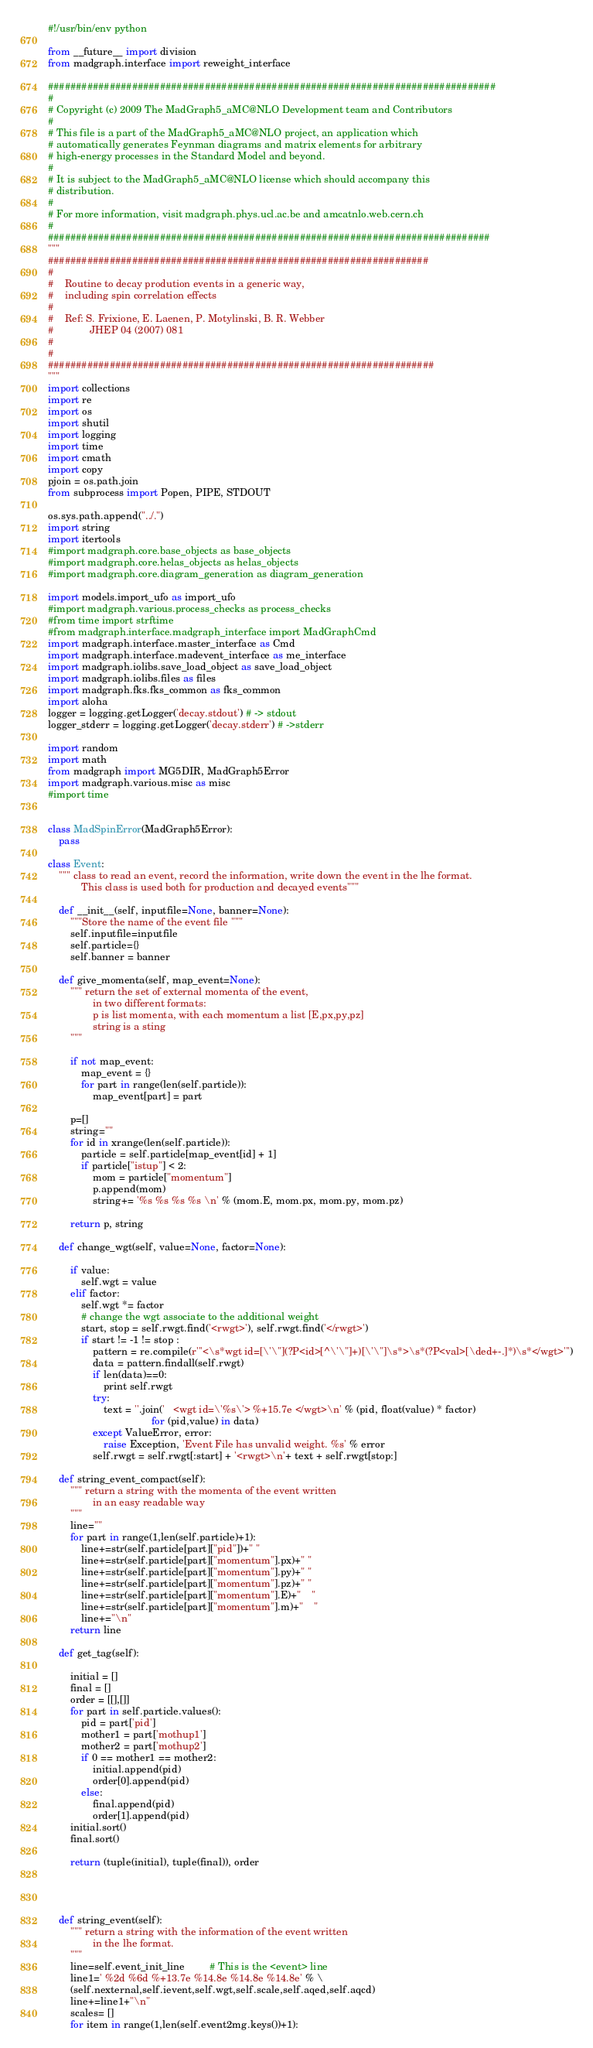<code> <loc_0><loc_0><loc_500><loc_500><_Python_>#!/usr/bin/env python

from __future__ import division
from madgraph.interface import reweight_interface

################################################################################
#
# Copyright (c) 2009 The MadGraph5_aMC@NLO Development team and Contributors
#
# This file is a part of the MadGraph5_aMC@NLO project, an application which 
# automatically generates Feynman diagrams and matrix elements for arbitrary
# high-energy processes in the Standard Model and beyond.
#
# It is subject to the MadGraph5_aMC@NLO license which should accompany this 
# distribution.
#
# For more information, visit madgraph.phys.ucl.ac.be and amcatnlo.web.cern.ch
#
###############################################################################
"""
####################################################################
#
#    Routine to decay prodution events in a generic way, 
#    including spin correlation effects
#
#    Ref: S. Frixione, E. Laenen, P. Motylinski, B. R. Webber
#             JHEP 04 (2007) 081
#
#
#####################################################################
"""
import collections
import re
import os
import shutil
import logging
import time
import cmath
import copy
pjoin = os.path.join
from subprocess import Popen, PIPE, STDOUT

os.sys.path.append("../.")
import string
import itertools
#import madgraph.core.base_objects as base_objects
#import madgraph.core.helas_objects as helas_objects
#import madgraph.core.diagram_generation as diagram_generation

import models.import_ufo as import_ufo
#import madgraph.various.process_checks as process_checks
#from time import strftime
#from madgraph.interface.madgraph_interface import MadGraphCmd
import madgraph.interface.master_interface as Cmd
import madgraph.interface.madevent_interface as me_interface
import madgraph.iolibs.save_load_object as save_load_object
import madgraph.iolibs.files as files
import madgraph.fks.fks_common as fks_common
import aloha
logger = logging.getLogger('decay.stdout') # -> stdout
logger_stderr = logging.getLogger('decay.stderr') # ->stderr

import random 
import math
from madgraph import MG5DIR, MadGraph5Error
import madgraph.various.misc as misc
#import time


class MadSpinError(MadGraph5Error):
    pass

class Event:
    """ class to read an event, record the information, write down the event in the lhe format.
            This class is used both for production and decayed events"""

    def __init__(self, inputfile=None, banner=None):
        """Store the name of the event file """
        self.inputfile=inputfile
        self.particle={}
        self.banner = banner

    def give_momenta(self, map_event=None):
        """ return the set of external momenta of the event, 
                in two different formats:
                p is list momenta, with each momentum a list [E,px,py,pz]
                string is a sting
        """
        
        if not map_event:
            map_event = {}
            for part in range(len(self.particle)):
                map_event[part] = part
                
        p=[]
        string=""
        for id in xrange(len(self.particle)):
            particle = self.particle[map_event[id] + 1]
            if particle["istup"] < 2:
                mom = particle["momentum"]
                p.append(mom)
                string+= '%s %s %s %s \n' % (mom.E, mom.px, mom.py, mom.pz)

        return p, string 
    
    def change_wgt(self, value=None, factor=None):
        
        if value:
            self.wgt = value
        elif factor:
            self.wgt *= factor
            # change the wgt associate to the additional weight
            start, stop = self.rwgt.find('<rwgt>'), self.rwgt.find('</rwgt>')
            if start != -1 != stop :
                pattern = re.compile(r'''<\s*wgt id=[\'\"](?P<id>[^\'\"]+)[\'\"]\s*>\s*(?P<val>[\ded+-.]*)\s*</wgt>''')
                data = pattern.findall(self.rwgt)
                if len(data)==0:
                    print self.rwgt
                try:
                    text = ''.join('   <wgt id=\'%s\'> %+15.7e </wgt>\n' % (pid, float(value) * factor)
                                     for (pid,value) in data) 
                except ValueError, error:
                    raise Exception, 'Event File has unvalid weight. %s' % error
                self.rwgt = self.rwgt[:start] + '<rwgt>\n'+ text + self.rwgt[stop:]          

    def string_event_compact(self):
        """ return a string with the momenta of the event written 
                in an easy readable way
        """
        line=""
        for part in range(1,len(self.particle)+1):
            line+=str(self.particle[part]["pid"])+" "
            line+=str(self.particle[part]["momentum"].px)+" "
            line+=str(self.particle[part]["momentum"].py)+" "
            line+=str(self.particle[part]["momentum"].pz)+" "
            line+=str(self.particle[part]["momentum"].E)+"    " 
            line+=str(self.particle[part]["momentum"].m)+"    " 
            line+="\n"
        return line
    
    def get_tag(self):
        
        initial = []
        final = []
        order = [[],[]]
        for part in self.particle.values():
            pid = part['pid']
            mother1 = part['mothup1']
            mother2 = part['mothup2']
            if 0 == mother1 == mother2:
                initial.append(pid)
                order[0].append(pid)
            else:
                final.append(pid)
                order[1].append(pid)
        initial.sort()
        final.sort()

        return (tuple(initial), tuple(final)), order
 
        
    

    def string_event(self):
        """ return a string with the information of the event written 
                in the lhe format.
        """
        line=self.event_init_line         # This is the <event> line
        line1=' %2d %6d %+13.7e %14.8e %14.8e %14.8e' % \
        (self.nexternal,self.ievent,self.wgt,self.scale,self.aqed,self.aqcd)
        line+=line1+"\n"
        scales= []
        for item in range(1,len(self.event2mg.keys())+1):</code> 